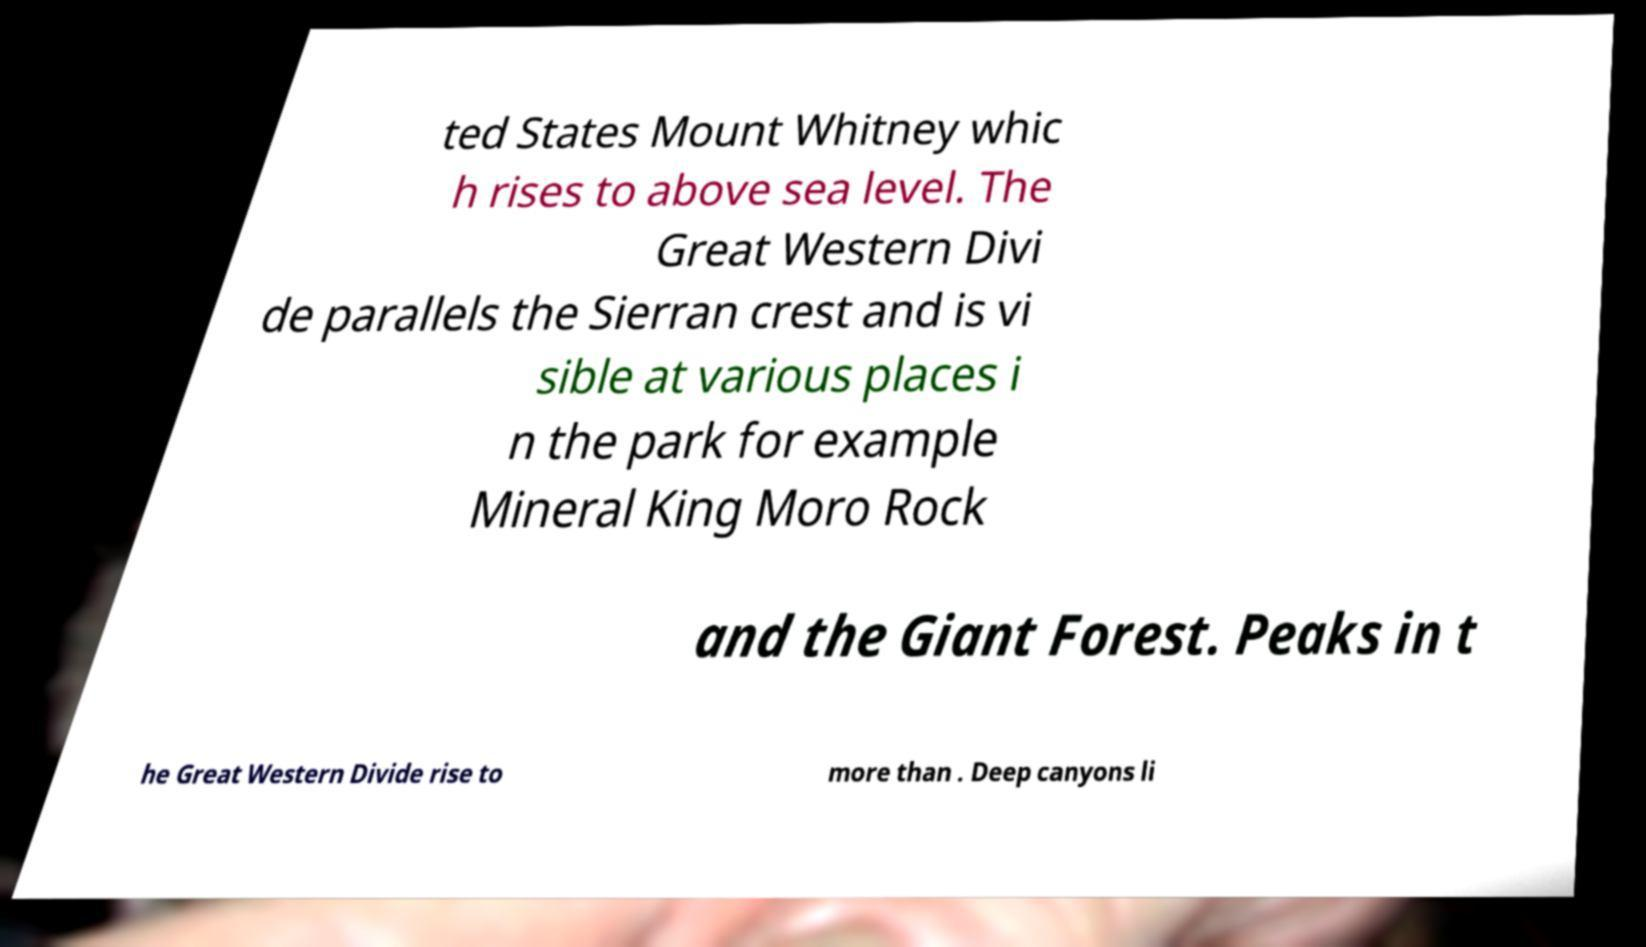Could you assist in decoding the text presented in this image and type it out clearly? ted States Mount Whitney whic h rises to above sea level. The Great Western Divi de parallels the Sierran crest and is vi sible at various places i n the park for example Mineral King Moro Rock and the Giant Forest. Peaks in t he Great Western Divide rise to more than . Deep canyons li 